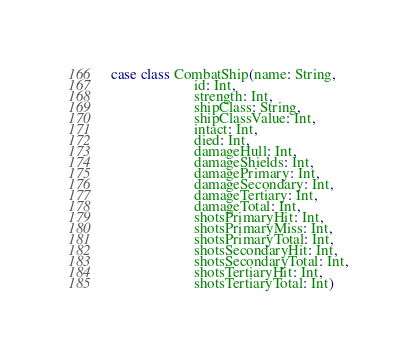<code> <loc_0><loc_0><loc_500><loc_500><_Scala_>case class CombatShip(name: String,
                      id: Int,
                      strength: Int,
                      shipClass: String,
                      shipClassValue: Int,
                      intact: Int,
                      died: Int,
                      damageHull: Int,
                      damageShields: Int,
                      damagePrimary: Int,
                      damageSecondary: Int,
                      damageTertiary: Int,
                      damageTotal: Int,
                      shotsPrimaryHit: Int,
                      shotsPrimaryMiss: Int,
                      shotsPrimaryTotal: Int,
                      shotsSecondaryHit: Int,
                      shotsSecondaryTotal: Int,
                      shotsTertiaryHit: Int,
                      shotsTertiaryTotal: Int)
</code> 